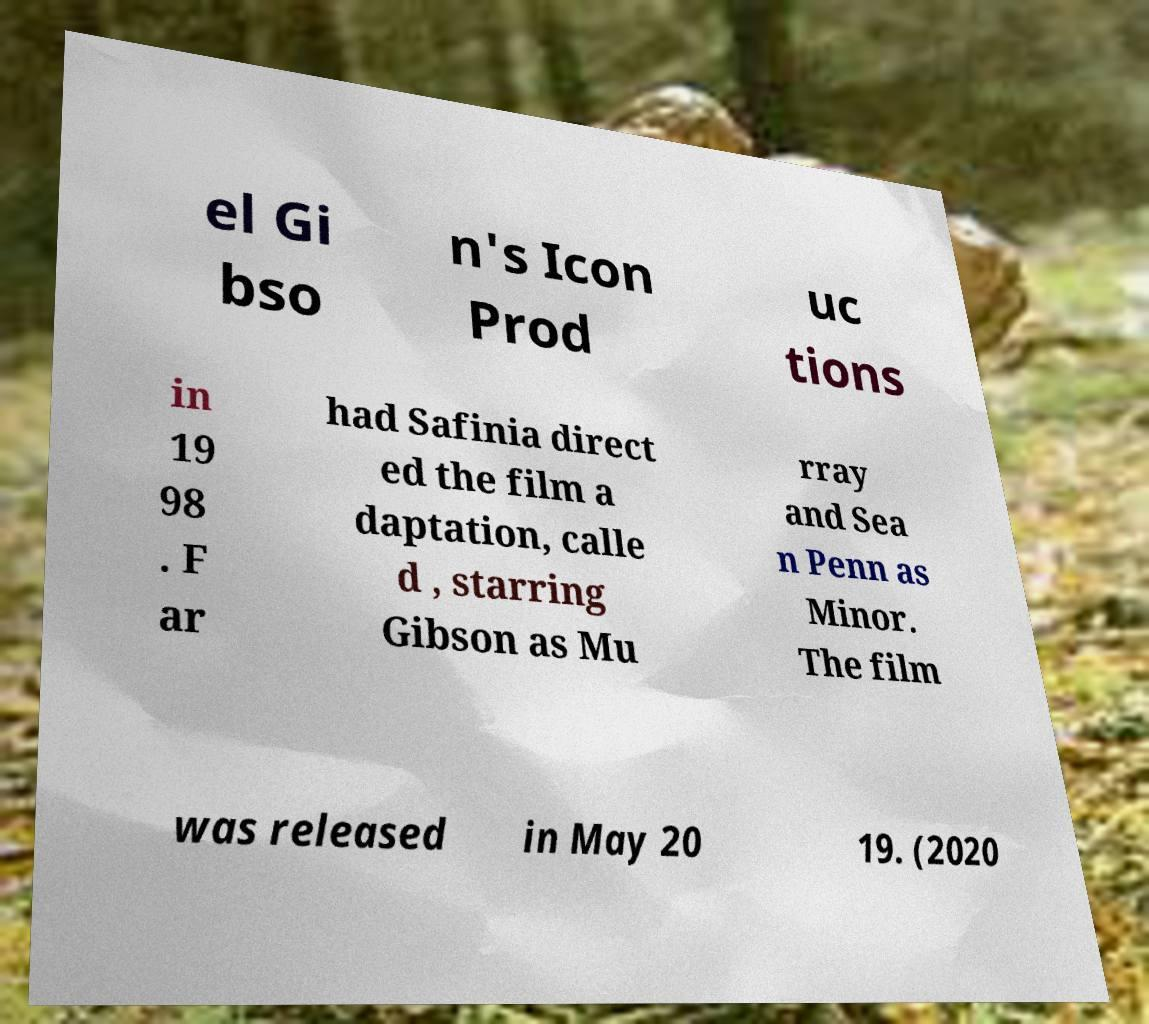I need the written content from this picture converted into text. Can you do that? el Gi bso n's Icon Prod uc tions in 19 98 . F ar had Safinia direct ed the film a daptation, calle d , starring Gibson as Mu rray and Sea n Penn as Minor. The film was released in May 20 19. (2020 